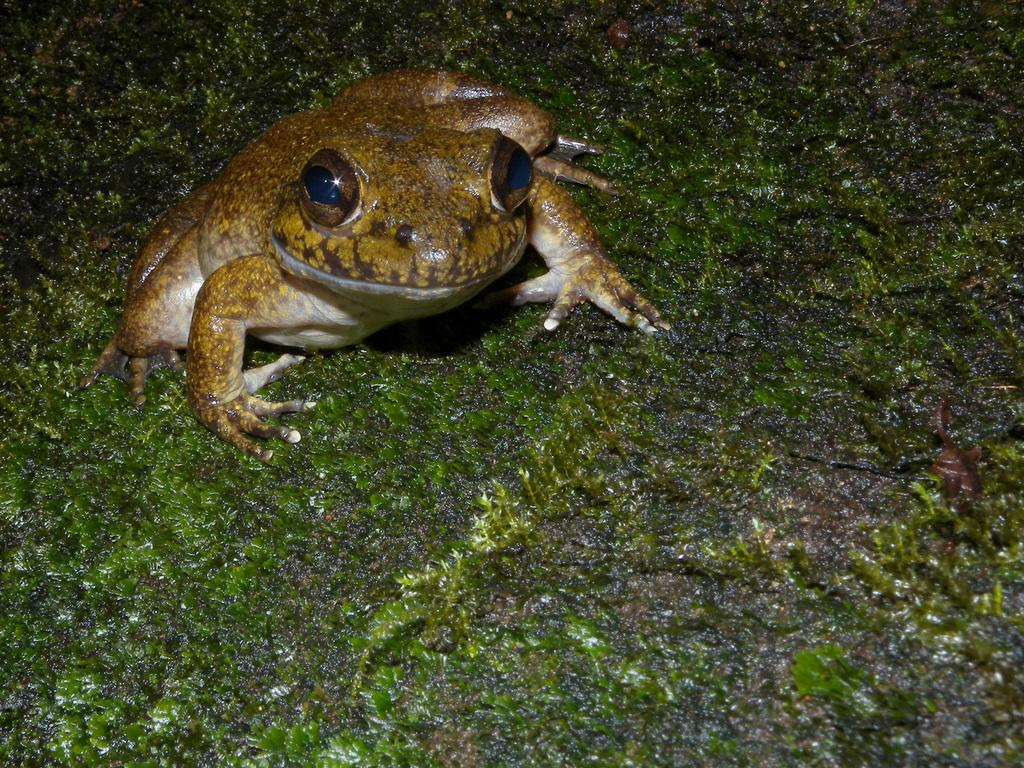What type of animal is present in the image? There is a frog in the image. How many rabbits can be seen in the image? There are no rabbits present in the image; it features a frog. What type of egg is being used to wash the frog in the image? There is no egg or washing activity depicted in the image; it simply shows a frog. 